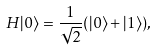<formula> <loc_0><loc_0><loc_500><loc_500>H | 0 \rangle = \frac { 1 } { \sqrt { 2 } } ( | 0 \rangle + | 1 \rangle ) ,</formula> 